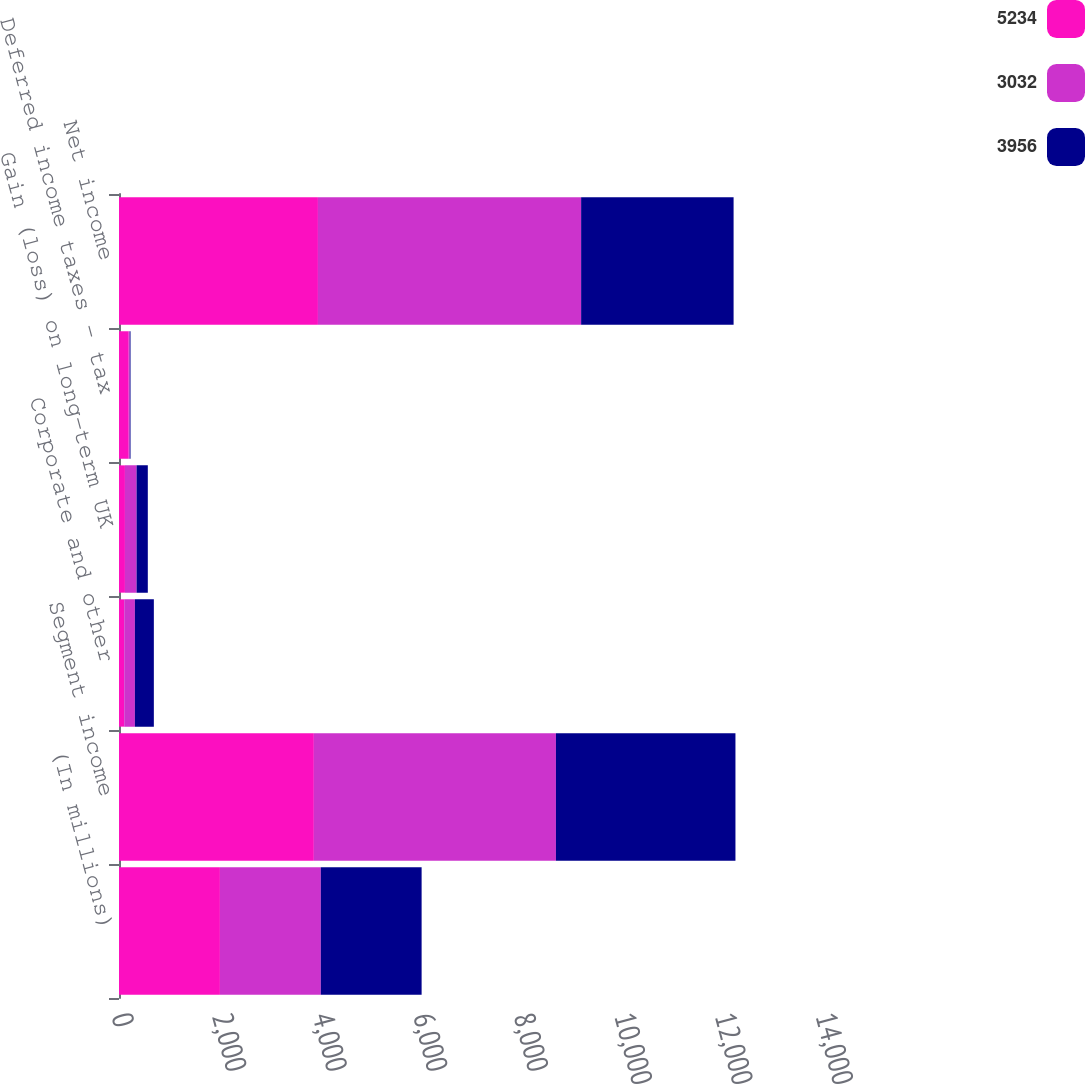Convert chart to OTSL. <chart><loc_0><loc_0><loc_500><loc_500><stacked_bar_chart><ecel><fcel>(In millions)<fcel>Segment income<fcel>Corporate and other<fcel>Gain (loss) on long-term UK<fcel>Deferred income taxes - tax<fcel>Net income<nl><fcel>5234<fcel>2007<fcel>3875<fcel>104<fcel>118<fcel>193<fcel>3956<nl><fcel>3032<fcel>2006<fcel>4814<fcel>212<fcel>232<fcel>21<fcel>5234<nl><fcel>3956<fcel>2005<fcel>3570<fcel>377<fcel>223<fcel>15<fcel>3032<nl></chart> 